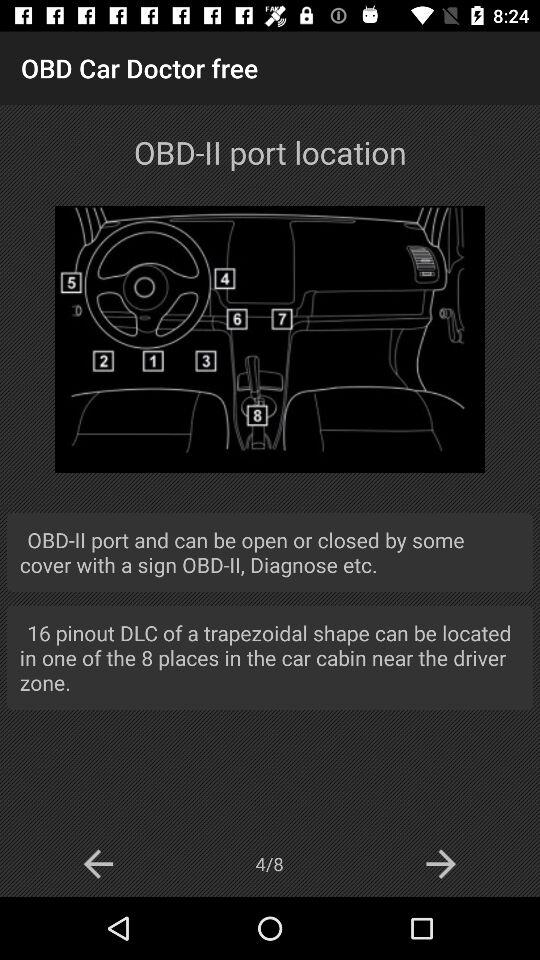How many places can the OBD-II port be located in?
Answer the question using a single word or phrase. 8 